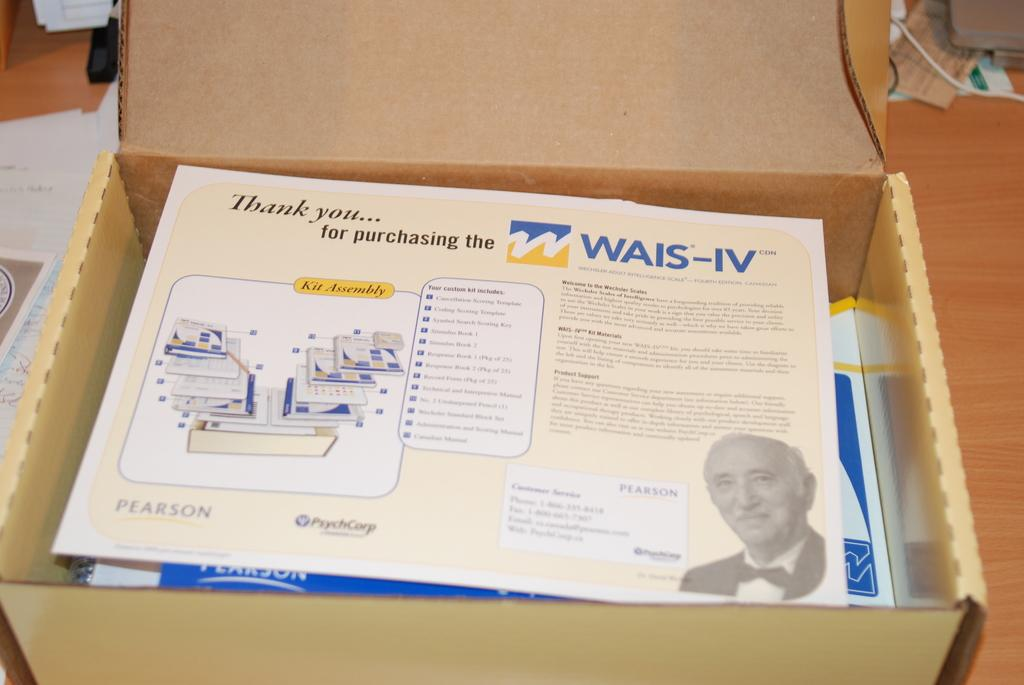What is inside the box that is visible in the image? There is a box with papers in the image. What can be seen on the papers in the box? There is writing on the papers, and there is an image of a person on the papers. What else is on the floor in the image besides the box? There are other items on the floor in the image. What type of holiday is being celebrated in the image? There is no indication of a holiday being celebrated in the image. How does the carriage fit into the scene depicted in the image? There is no carriage present in the image. 